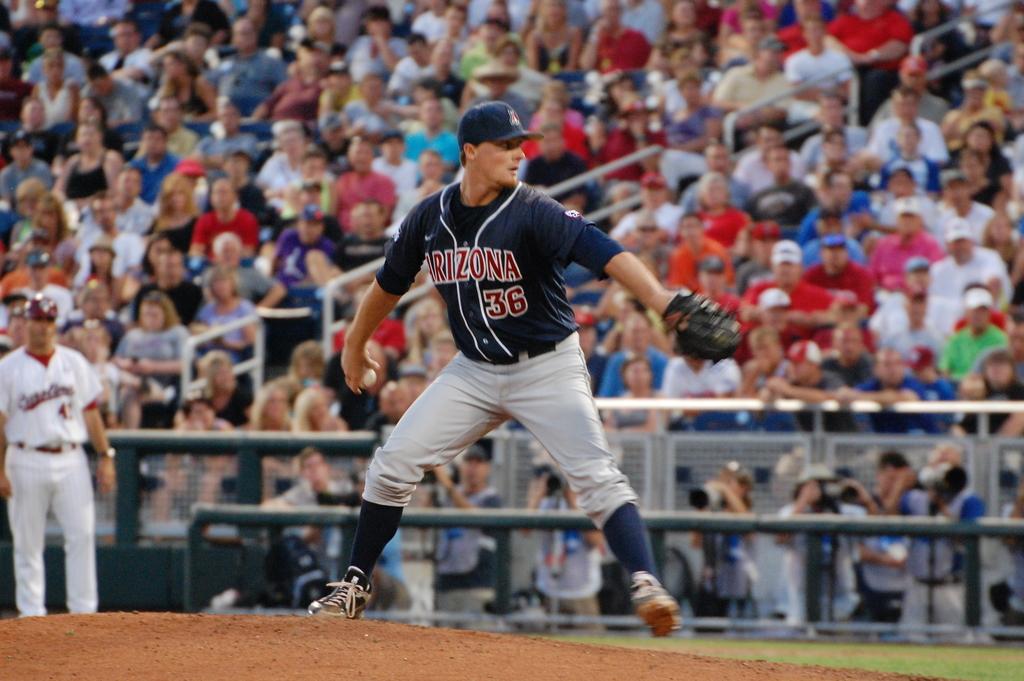What team does the pitcher play for?
Give a very brief answer. Arizona. What is the pitchers number?
Give a very brief answer. 36. 